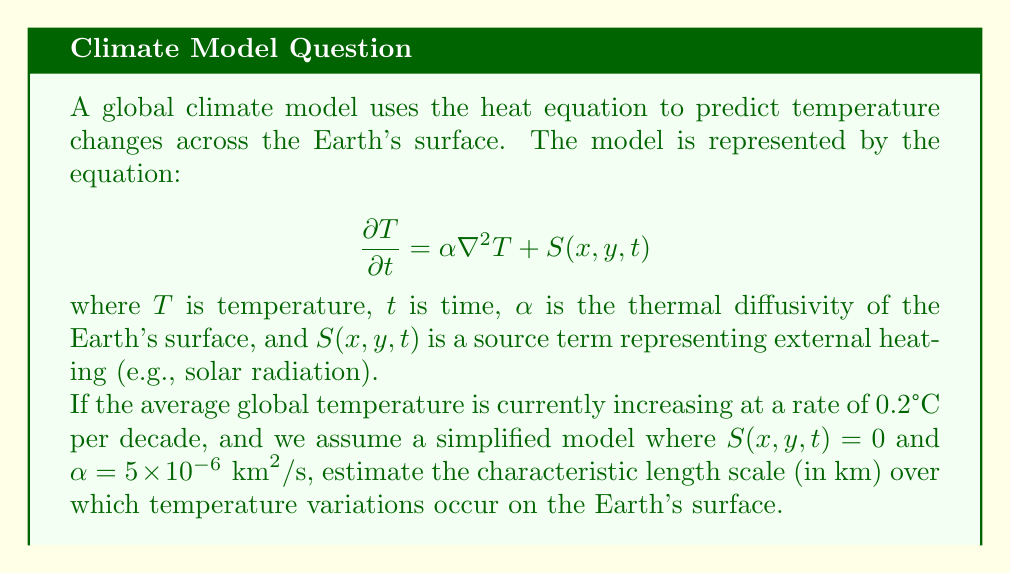Can you answer this question? To solve this problem, we'll use dimensional analysis and the given heat equation:

1) The heat equation without the source term is:

   $$\frac{\partial T}{\partial t} = \alpha \nabla^2 T$$

2) We can estimate the order of magnitude of each term:
   
   $$\frac{\Delta T}{\Delta t} \sim \alpha \frac{\Delta T}{L^2}$$

   where $L$ is the characteristic length scale we're looking for.

3) We're given that the temperature is increasing at 0.2°C per decade. Let's convert this to SI units:
   
   $$\frac{\Delta T}{\Delta t} = \frac{0.2°C}{10 \text{ years}} = \frac{0.2°C}{3.15 \times 10^8 \text{ s}} \approx 6.35 \times 10^{-10} °C/s$$

4) We're also given $\alpha = 5 \times 10^{-6} \text{ km}^2/\text{s}$. Let's keep it in these units for now.

5) Substituting these into our dimensional analysis equation:

   $$6.35 \times 10^{-10} \sim 5 \times 10^{-6} \frac{1}{L^2}$$

6) Solving for $L$:

   $$L^2 \sim \frac{5 \times 10^{-6}}{6.35 \times 10^{-10}} \approx 7.87 \times 10^3$$

7) Taking the square root:

   $$L \sim \sqrt{7.87 \times 10^3} \approx 89 \text{ km}$$

This gives us an estimate of the characteristic length scale over which temperature variations occur.
Answer: 89 km 